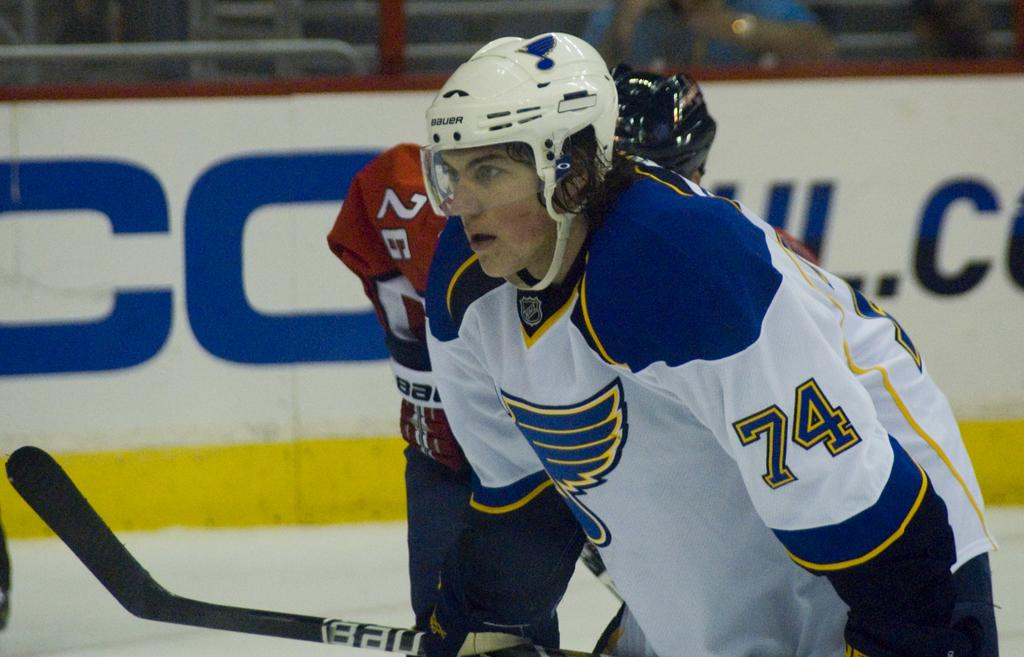What can be seen in the image besides the people and the stick? There is a poster and some objects visible in the background of the image. What are the people wearing on their heads in the image? The two people in the image are wearing helmets. What is the condition of the background in the image? The background is blurry. What is the main object in the foreground of the image? There is a stick in the image. What type of crayon can be seen in the image? There is no crayon present in the image. How does the acoustics of the room affect the people in the image? There is no information about the acoustics of the room in the image, so it cannot be determined how it affects the people. 